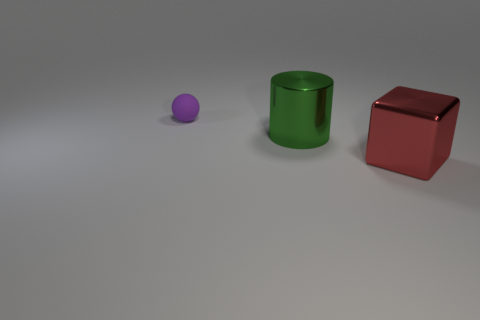How many objects have the same size as the cylinder? From the perspective provided by the image, it appears that none of the objects share the exact same size as the cylinder. The sphere is smaller and the cube is larger in size compared to the cylinder. However, without precise measurements, we cannot conclusively determine if they have the same size based on this image alone. 